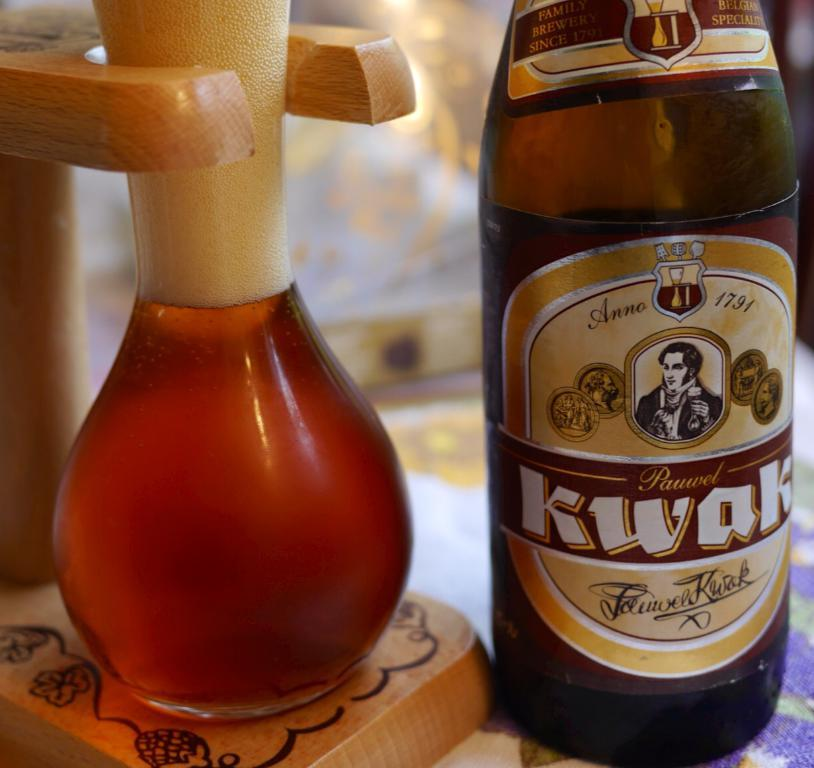Provide a one-sentence caption for the provided image. The beer in the container is Pauwel Kwak. 